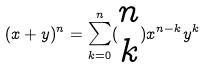Convert formula to latex. <formula><loc_0><loc_0><loc_500><loc_500>( x + y ) ^ { n } = \sum _ { k = 0 } ^ { n } ( \begin{matrix} n \\ k \end{matrix} ) x ^ { n - k } y ^ { k }</formula> 